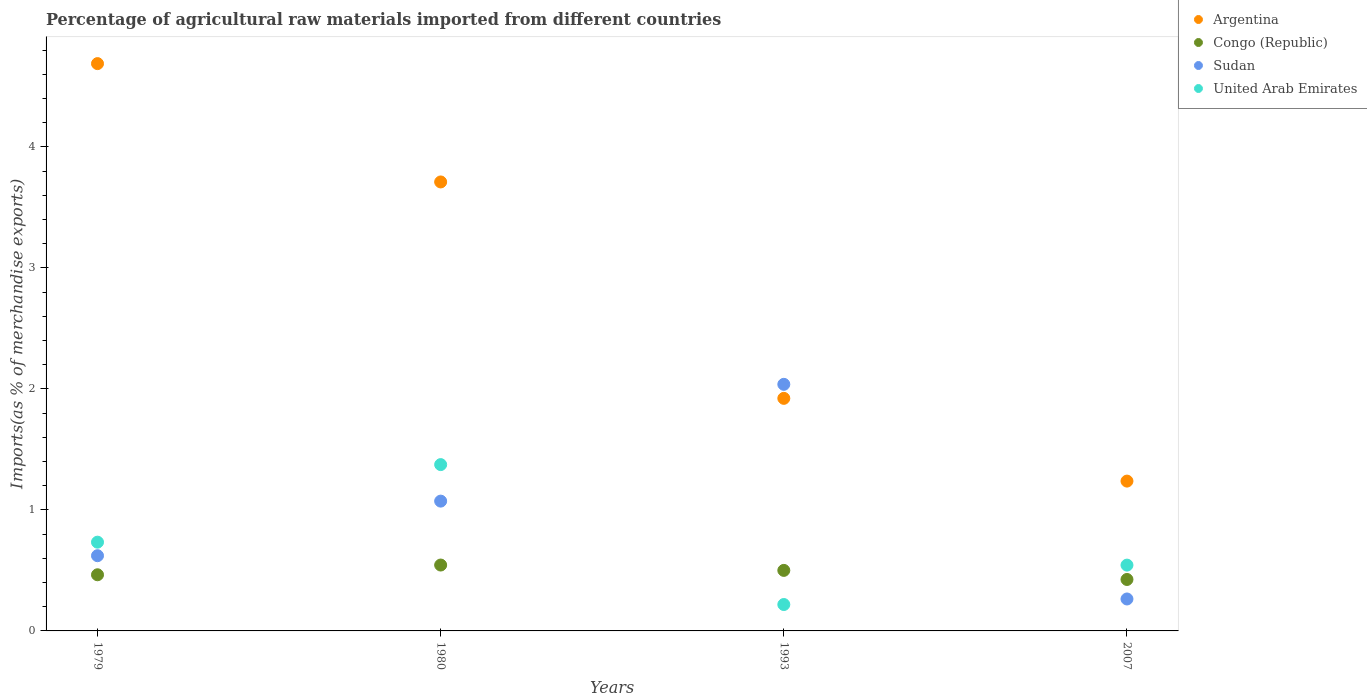How many different coloured dotlines are there?
Your response must be concise. 4. What is the percentage of imports to different countries in Argentina in 1979?
Offer a terse response. 4.69. Across all years, what is the maximum percentage of imports to different countries in Congo (Republic)?
Offer a very short reply. 0.54. Across all years, what is the minimum percentage of imports to different countries in Congo (Republic)?
Give a very brief answer. 0.43. What is the total percentage of imports to different countries in Sudan in the graph?
Provide a short and direct response. 4. What is the difference between the percentage of imports to different countries in United Arab Emirates in 1979 and that in 1993?
Make the answer very short. 0.52. What is the difference between the percentage of imports to different countries in Congo (Republic) in 1979 and the percentage of imports to different countries in United Arab Emirates in 2007?
Your response must be concise. -0.08. What is the average percentage of imports to different countries in Sudan per year?
Provide a succinct answer. 1. In the year 1980, what is the difference between the percentage of imports to different countries in Argentina and percentage of imports to different countries in Congo (Republic)?
Your answer should be very brief. 3.17. In how many years, is the percentage of imports to different countries in Argentina greater than 4.4 %?
Your answer should be very brief. 1. What is the ratio of the percentage of imports to different countries in Congo (Republic) in 1980 to that in 2007?
Provide a succinct answer. 1.28. What is the difference between the highest and the second highest percentage of imports to different countries in Congo (Republic)?
Your response must be concise. 0.04. What is the difference between the highest and the lowest percentage of imports to different countries in Congo (Republic)?
Offer a very short reply. 0.12. In how many years, is the percentage of imports to different countries in Sudan greater than the average percentage of imports to different countries in Sudan taken over all years?
Provide a short and direct response. 2. Is the sum of the percentage of imports to different countries in Argentina in 1979 and 1980 greater than the maximum percentage of imports to different countries in Congo (Republic) across all years?
Your answer should be very brief. Yes. Is it the case that in every year, the sum of the percentage of imports to different countries in United Arab Emirates and percentage of imports to different countries in Congo (Republic)  is greater than the percentage of imports to different countries in Sudan?
Offer a very short reply. No. Is the percentage of imports to different countries in Argentina strictly greater than the percentage of imports to different countries in Congo (Republic) over the years?
Your answer should be very brief. Yes. How many dotlines are there?
Offer a terse response. 4. What is the difference between two consecutive major ticks on the Y-axis?
Make the answer very short. 1. Does the graph contain any zero values?
Your answer should be very brief. No. Does the graph contain grids?
Give a very brief answer. No. How many legend labels are there?
Give a very brief answer. 4. How are the legend labels stacked?
Make the answer very short. Vertical. What is the title of the graph?
Make the answer very short. Percentage of agricultural raw materials imported from different countries. Does "Guam" appear as one of the legend labels in the graph?
Your response must be concise. No. What is the label or title of the Y-axis?
Offer a terse response. Imports(as % of merchandise exports). What is the Imports(as % of merchandise exports) in Argentina in 1979?
Your answer should be compact. 4.69. What is the Imports(as % of merchandise exports) in Congo (Republic) in 1979?
Your answer should be compact. 0.46. What is the Imports(as % of merchandise exports) in Sudan in 1979?
Your response must be concise. 0.62. What is the Imports(as % of merchandise exports) of United Arab Emirates in 1979?
Your answer should be compact. 0.73. What is the Imports(as % of merchandise exports) of Argentina in 1980?
Offer a terse response. 3.71. What is the Imports(as % of merchandise exports) of Congo (Republic) in 1980?
Ensure brevity in your answer.  0.54. What is the Imports(as % of merchandise exports) in Sudan in 1980?
Offer a very short reply. 1.07. What is the Imports(as % of merchandise exports) in United Arab Emirates in 1980?
Your answer should be compact. 1.37. What is the Imports(as % of merchandise exports) of Argentina in 1993?
Your response must be concise. 1.92. What is the Imports(as % of merchandise exports) of Congo (Republic) in 1993?
Ensure brevity in your answer.  0.5. What is the Imports(as % of merchandise exports) in Sudan in 1993?
Make the answer very short. 2.04. What is the Imports(as % of merchandise exports) of United Arab Emirates in 1993?
Your answer should be compact. 0.22. What is the Imports(as % of merchandise exports) in Argentina in 2007?
Keep it short and to the point. 1.24. What is the Imports(as % of merchandise exports) in Congo (Republic) in 2007?
Provide a short and direct response. 0.43. What is the Imports(as % of merchandise exports) in Sudan in 2007?
Your answer should be very brief. 0.26. What is the Imports(as % of merchandise exports) in United Arab Emirates in 2007?
Ensure brevity in your answer.  0.54. Across all years, what is the maximum Imports(as % of merchandise exports) of Argentina?
Provide a succinct answer. 4.69. Across all years, what is the maximum Imports(as % of merchandise exports) in Congo (Republic)?
Your answer should be very brief. 0.54. Across all years, what is the maximum Imports(as % of merchandise exports) in Sudan?
Ensure brevity in your answer.  2.04. Across all years, what is the maximum Imports(as % of merchandise exports) of United Arab Emirates?
Ensure brevity in your answer.  1.37. Across all years, what is the minimum Imports(as % of merchandise exports) in Argentina?
Keep it short and to the point. 1.24. Across all years, what is the minimum Imports(as % of merchandise exports) of Congo (Republic)?
Offer a terse response. 0.43. Across all years, what is the minimum Imports(as % of merchandise exports) of Sudan?
Offer a very short reply. 0.26. Across all years, what is the minimum Imports(as % of merchandise exports) of United Arab Emirates?
Your response must be concise. 0.22. What is the total Imports(as % of merchandise exports) of Argentina in the graph?
Your answer should be compact. 11.56. What is the total Imports(as % of merchandise exports) of Congo (Republic) in the graph?
Make the answer very short. 1.93. What is the total Imports(as % of merchandise exports) in Sudan in the graph?
Keep it short and to the point. 4. What is the total Imports(as % of merchandise exports) in United Arab Emirates in the graph?
Your response must be concise. 2.87. What is the difference between the Imports(as % of merchandise exports) of Argentina in 1979 and that in 1980?
Make the answer very short. 0.98. What is the difference between the Imports(as % of merchandise exports) in Congo (Republic) in 1979 and that in 1980?
Your response must be concise. -0.08. What is the difference between the Imports(as % of merchandise exports) of Sudan in 1979 and that in 1980?
Offer a terse response. -0.45. What is the difference between the Imports(as % of merchandise exports) in United Arab Emirates in 1979 and that in 1980?
Provide a short and direct response. -0.64. What is the difference between the Imports(as % of merchandise exports) of Argentina in 1979 and that in 1993?
Offer a very short reply. 2.77. What is the difference between the Imports(as % of merchandise exports) in Congo (Republic) in 1979 and that in 1993?
Your answer should be very brief. -0.04. What is the difference between the Imports(as % of merchandise exports) in Sudan in 1979 and that in 1993?
Offer a terse response. -1.42. What is the difference between the Imports(as % of merchandise exports) of United Arab Emirates in 1979 and that in 1993?
Your answer should be compact. 0.52. What is the difference between the Imports(as % of merchandise exports) in Argentina in 1979 and that in 2007?
Ensure brevity in your answer.  3.45. What is the difference between the Imports(as % of merchandise exports) of Congo (Republic) in 1979 and that in 2007?
Give a very brief answer. 0.04. What is the difference between the Imports(as % of merchandise exports) of Sudan in 1979 and that in 2007?
Ensure brevity in your answer.  0.36. What is the difference between the Imports(as % of merchandise exports) of United Arab Emirates in 1979 and that in 2007?
Your answer should be compact. 0.19. What is the difference between the Imports(as % of merchandise exports) of Argentina in 1980 and that in 1993?
Your answer should be very brief. 1.79. What is the difference between the Imports(as % of merchandise exports) in Congo (Republic) in 1980 and that in 1993?
Your answer should be very brief. 0.04. What is the difference between the Imports(as % of merchandise exports) of Sudan in 1980 and that in 1993?
Keep it short and to the point. -0.97. What is the difference between the Imports(as % of merchandise exports) in United Arab Emirates in 1980 and that in 1993?
Keep it short and to the point. 1.16. What is the difference between the Imports(as % of merchandise exports) of Argentina in 1980 and that in 2007?
Your response must be concise. 2.47. What is the difference between the Imports(as % of merchandise exports) of Congo (Republic) in 1980 and that in 2007?
Provide a succinct answer. 0.12. What is the difference between the Imports(as % of merchandise exports) in Sudan in 1980 and that in 2007?
Provide a short and direct response. 0.81. What is the difference between the Imports(as % of merchandise exports) of United Arab Emirates in 1980 and that in 2007?
Provide a succinct answer. 0.83. What is the difference between the Imports(as % of merchandise exports) of Argentina in 1993 and that in 2007?
Keep it short and to the point. 0.68. What is the difference between the Imports(as % of merchandise exports) of Congo (Republic) in 1993 and that in 2007?
Give a very brief answer. 0.08. What is the difference between the Imports(as % of merchandise exports) in Sudan in 1993 and that in 2007?
Offer a very short reply. 1.77. What is the difference between the Imports(as % of merchandise exports) in United Arab Emirates in 1993 and that in 2007?
Ensure brevity in your answer.  -0.33. What is the difference between the Imports(as % of merchandise exports) in Argentina in 1979 and the Imports(as % of merchandise exports) in Congo (Republic) in 1980?
Ensure brevity in your answer.  4.14. What is the difference between the Imports(as % of merchandise exports) of Argentina in 1979 and the Imports(as % of merchandise exports) of Sudan in 1980?
Your response must be concise. 3.62. What is the difference between the Imports(as % of merchandise exports) of Argentina in 1979 and the Imports(as % of merchandise exports) of United Arab Emirates in 1980?
Keep it short and to the point. 3.31. What is the difference between the Imports(as % of merchandise exports) of Congo (Republic) in 1979 and the Imports(as % of merchandise exports) of Sudan in 1980?
Offer a very short reply. -0.61. What is the difference between the Imports(as % of merchandise exports) of Congo (Republic) in 1979 and the Imports(as % of merchandise exports) of United Arab Emirates in 1980?
Provide a succinct answer. -0.91. What is the difference between the Imports(as % of merchandise exports) of Sudan in 1979 and the Imports(as % of merchandise exports) of United Arab Emirates in 1980?
Offer a terse response. -0.75. What is the difference between the Imports(as % of merchandise exports) of Argentina in 1979 and the Imports(as % of merchandise exports) of Congo (Republic) in 1993?
Make the answer very short. 4.19. What is the difference between the Imports(as % of merchandise exports) in Argentina in 1979 and the Imports(as % of merchandise exports) in Sudan in 1993?
Ensure brevity in your answer.  2.65. What is the difference between the Imports(as % of merchandise exports) of Argentina in 1979 and the Imports(as % of merchandise exports) of United Arab Emirates in 1993?
Offer a very short reply. 4.47. What is the difference between the Imports(as % of merchandise exports) of Congo (Republic) in 1979 and the Imports(as % of merchandise exports) of Sudan in 1993?
Give a very brief answer. -1.57. What is the difference between the Imports(as % of merchandise exports) of Congo (Republic) in 1979 and the Imports(as % of merchandise exports) of United Arab Emirates in 1993?
Ensure brevity in your answer.  0.25. What is the difference between the Imports(as % of merchandise exports) in Sudan in 1979 and the Imports(as % of merchandise exports) in United Arab Emirates in 1993?
Provide a short and direct response. 0.4. What is the difference between the Imports(as % of merchandise exports) in Argentina in 1979 and the Imports(as % of merchandise exports) in Congo (Republic) in 2007?
Provide a succinct answer. 4.26. What is the difference between the Imports(as % of merchandise exports) of Argentina in 1979 and the Imports(as % of merchandise exports) of Sudan in 2007?
Provide a short and direct response. 4.42. What is the difference between the Imports(as % of merchandise exports) of Argentina in 1979 and the Imports(as % of merchandise exports) of United Arab Emirates in 2007?
Keep it short and to the point. 4.14. What is the difference between the Imports(as % of merchandise exports) of Congo (Republic) in 1979 and the Imports(as % of merchandise exports) of United Arab Emirates in 2007?
Offer a very short reply. -0.08. What is the difference between the Imports(as % of merchandise exports) in Sudan in 1979 and the Imports(as % of merchandise exports) in United Arab Emirates in 2007?
Offer a terse response. 0.08. What is the difference between the Imports(as % of merchandise exports) of Argentina in 1980 and the Imports(as % of merchandise exports) of Congo (Republic) in 1993?
Provide a short and direct response. 3.21. What is the difference between the Imports(as % of merchandise exports) of Argentina in 1980 and the Imports(as % of merchandise exports) of Sudan in 1993?
Provide a short and direct response. 1.67. What is the difference between the Imports(as % of merchandise exports) in Argentina in 1980 and the Imports(as % of merchandise exports) in United Arab Emirates in 1993?
Offer a very short reply. 3.49. What is the difference between the Imports(as % of merchandise exports) in Congo (Republic) in 1980 and the Imports(as % of merchandise exports) in Sudan in 1993?
Give a very brief answer. -1.49. What is the difference between the Imports(as % of merchandise exports) in Congo (Republic) in 1980 and the Imports(as % of merchandise exports) in United Arab Emirates in 1993?
Your answer should be compact. 0.33. What is the difference between the Imports(as % of merchandise exports) of Sudan in 1980 and the Imports(as % of merchandise exports) of United Arab Emirates in 1993?
Ensure brevity in your answer.  0.85. What is the difference between the Imports(as % of merchandise exports) of Argentina in 1980 and the Imports(as % of merchandise exports) of Congo (Republic) in 2007?
Offer a terse response. 3.29. What is the difference between the Imports(as % of merchandise exports) of Argentina in 1980 and the Imports(as % of merchandise exports) of Sudan in 2007?
Your answer should be compact. 3.45. What is the difference between the Imports(as % of merchandise exports) of Argentina in 1980 and the Imports(as % of merchandise exports) of United Arab Emirates in 2007?
Offer a terse response. 3.17. What is the difference between the Imports(as % of merchandise exports) of Congo (Republic) in 1980 and the Imports(as % of merchandise exports) of Sudan in 2007?
Provide a succinct answer. 0.28. What is the difference between the Imports(as % of merchandise exports) in Congo (Republic) in 1980 and the Imports(as % of merchandise exports) in United Arab Emirates in 2007?
Keep it short and to the point. 0. What is the difference between the Imports(as % of merchandise exports) of Sudan in 1980 and the Imports(as % of merchandise exports) of United Arab Emirates in 2007?
Offer a terse response. 0.53. What is the difference between the Imports(as % of merchandise exports) of Argentina in 1993 and the Imports(as % of merchandise exports) of Congo (Republic) in 2007?
Offer a terse response. 1.5. What is the difference between the Imports(as % of merchandise exports) in Argentina in 1993 and the Imports(as % of merchandise exports) in Sudan in 2007?
Your answer should be very brief. 1.66. What is the difference between the Imports(as % of merchandise exports) in Argentina in 1993 and the Imports(as % of merchandise exports) in United Arab Emirates in 2007?
Offer a terse response. 1.38. What is the difference between the Imports(as % of merchandise exports) of Congo (Republic) in 1993 and the Imports(as % of merchandise exports) of Sudan in 2007?
Keep it short and to the point. 0.24. What is the difference between the Imports(as % of merchandise exports) of Congo (Republic) in 1993 and the Imports(as % of merchandise exports) of United Arab Emirates in 2007?
Provide a succinct answer. -0.04. What is the difference between the Imports(as % of merchandise exports) of Sudan in 1993 and the Imports(as % of merchandise exports) of United Arab Emirates in 2007?
Make the answer very short. 1.49. What is the average Imports(as % of merchandise exports) of Argentina per year?
Offer a terse response. 2.89. What is the average Imports(as % of merchandise exports) in Congo (Republic) per year?
Make the answer very short. 0.48. What is the average Imports(as % of merchandise exports) of United Arab Emirates per year?
Offer a terse response. 0.72. In the year 1979, what is the difference between the Imports(as % of merchandise exports) of Argentina and Imports(as % of merchandise exports) of Congo (Republic)?
Offer a terse response. 4.22. In the year 1979, what is the difference between the Imports(as % of merchandise exports) of Argentina and Imports(as % of merchandise exports) of Sudan?
Provide a succinct answer. 4.07. In the year 1979, what is the difference between the Imports(as % of merchandise exports) in Argentina and Imports(as % of merchandise exports) in United Arab Emirates?
Offer a very short reply. 3.96. In the year 1979, what is the difference between the Imports(as % of merchandise exports) in Congo (Republic) and Imports(as % of merchandise exports) in Sudan?
Ensure brevity in your answer.  -0.16. In the year 1979, what is the difference between the Imports(as % of merchandise exports) in Congo (Republic) and Imports(as % of merchandise exports) in United Arab Emirates?
Your answer should be very brief. -0.27. In the year 1979, what is the difference between the Imports(as % of merchandise exports) in Sudan and Imports(as % of merchandise exports) in United Arab Emirates?
Give a very brief answer. -0.11. In the year 1980, what is the difference between the Imports(as % of merchandise exports) in Argentina and Imports(as % of merchandise exports) in Congo (Republic)?
Give a very brief answer. 3.17. In the year 1980, what is the difference between the Imports(as % of merchandise exports) in Argentina and Imports(as % of merchandise exports) in Sudan?
Your answer should be compact. 2.64. In the year 1980, what is the difference between the Imports(as % of merchandise exports) of Argentina and Imports(as % of merchandise exports) of United Arab Emirates?
Your answer should be very brief. 2.34. In the year 1980, what is the difference between the Imports(as % of merchandise exports) in Congo (Republic) and Imports(as % of merchandise exports) in Sudan?
Provide a succinct answer. -0.53. In the year 1980, what is the difference between the Imports(as % of merchandise exports) in Congo (Republic) and Imports(as % of merchandise exports) in United Arab Emirates?
Provide a short and direct response. -0.83. In the year 1980, what is the difference between the Imports(as % of merchandise exports) in Sudan and Imports(as % of merchandise exports) in United Arab Emirates?
Provide a succinct answer. -0.3. In the year 1993, what is the difference between the Imports(as % of merchandise exports) of Argentina and Imports(as % of merchandise exports) of Congo (Republic)?
Offer a terse response. 1.42. In the year 1993, what is the difference between the Imports(as % of merchandise exports) of Argentina and Imports(as % of merchandise exports) of Sudan?
Offer a terse response. -0.12. In the year 1993, what is the difference between the Imports(as % of merchandise exports) in Argentina and Imports(as % of merchandise exports) in United Arab Emirates?
Provide a succinct answer. 1.7. In the year 1993, what is the difference between the Imports(as % of merchandise exports) in Congo (Republic) and Imports(as % of merchandise exports) in Sudan?
Your answer should be compact. -1.54. In the year 1993, what is the difference between the Imports(as % of merchandise exports) of Congo (Republic) and Imports(as % of merchandise exports) of United Arab Emirates?
Keep it short and to the point. 0.28. In the year 1993, what is the difference between the Imports(as % of merchandise exports) of Sudan and Imports(as % of merchandise exports) of United Arab Emirates?
Provide a succinct answer. 1.82. In the year 2007, what is the difference between the Imports(as % of merchandise exports) in Argentina and Imports(as % of merchandise exports) in Congo (Republic)?
Provide a short and direct response. 0.81. In the year 2007, what is the difference between the Imports(as % of merchandise exports) of Argentina and Imports(as % of merchandise exports) of Sudan?
Offer a very short reply. 0.97. In the year 2007, what is the difference between the Imports(as % of merchandise exports) of Argentina and Imports(as % of merchandise exports) of United Arab Emirates?
Offer a very short reply. 0.69. In the year 2007, what is the difference between the Imports(as % of merchandise exports) of Congo (Republic) and Imports(as % of merchandise exports) of Sudan?
Offer a terse response. 0.16. In the year 2007, what is the difference between the Imports(as % of merchandise exports) of Congo (Republic) and Imports(as % of merchandise exports) of United Arab Emirates?
Ensure brevity in your answer.  -0.12. In the year 2007, what is the difference between the Imports(as % of merchandise exports) in Sudan and Imports(as % of merchandise exports) in United Arab Emirates?
Your response must be concise. -0.28. What is the ratio of the Imports(as % of merchandise exports) in Argentina in 1979 to that in 1980?
Make the answer very short. 1.26. What is the ratio of the Imports(as % of merchandise exports) in Congo (Republic) in 1979 to that in 1980?
Your response must be concise. 0.85. What is the ratio of the Imports(as % of merchandise exports) of Sudan in 1979 to that in 1980?
Provide a succinct answer. 0.58. What is the ratio of the Imports(as % of merchandise exports) in United Arab Emirates in 1979 to that in 1980?
Make the answer very short. 0.53. What is the ratio of the Imports(as % of merchandise exports) in Argentina in 1979 to that in 1993?
Your answer should be very brief. 2.44. What is the ratio of the Imports(as % of merchandise exports) in Congo (Republic) in 1979 to that in 1993?
Ensure brevity in your answer.  0.93. What is the ratio of the Imports(as % of merchandise exports) of Sudan in 1979 to that in 1993?
Provide a succinct answer. 0.3. What is the ratio of the Imports(as % of merchandise exports) of United Arab Emirates in 1979 to that in 1993?
Provide a short and direct response. 3.36. What is the ratio of the Imports(as % of merchandise exports) in Argentina in 1979 to that in 2007?
Your response must be concise. 3.79. What is the ratio of the Imports(as % of merchandise exports) of Congo (Republic) in 1979 to that in 2007?
Offer a very short reply. 1.09. What is the ratio of the Imports(as % of merchandise exports) of Sudan in 1979 to that in 2007?
Offer a terse response. 2.35. What is the ratio of the Imports(as % of merchandise exports) of United Arab Emirates in 1979 to that in 2007?
Offer a very short reply. 1.35. What is the ratio of the Imports(as % of merchandise exports) in Argentina in 1980 to that in 1993?
Your answer should be compact. 1.93. What is the ratio of the Imports(as % of merchandise exports) in Congo (Republic) in 1980 to that in 1993?
Your answer should be compact. 1.09. What is the ratio of the Imports(as % of merchandise exports) in Sudan in 1980 to that in 1993?
Make the answer very short. 0.53. What is the ratio of the Imports(as % of merchandise exports) in United Arab Emirates in 1980 to that in 1993?
Offer a very short reply. 6.3. What is the ratio of the Imports(as % of merchandise exports) in Argentina in 1980 to that in 2007?
Your answer should be very brief. 3. What is the ratio of the Imports(as % of merchandise exports) in Congo (Republic) in 1980 to that in 2007?
Provide a succinct answer. 1.28. What is the ratio of the Imports(as % of merchandise exports) of Sudan in 1980 to that in 2007?
Make the answer very short. 4.06. What is the ratio of the Imports(as % of merchandise exports) of United Arab Emirates in 1980 to that in 2007?
Provide a succinct answer. 2.53. What is the ratio of the Imports(as % of merchandise exports) in Argentina in 1993 to that in 2007?
Offer a terse response. 1.55. What is the ratio of the Imports(as % of merchandise exports) of Congo (Republic) in 1993 to that in 2007?
Offer a terse response. 1.18. What is the ratio of the Imports(as % of merchandise exports) in Sudan in 1993 to that in 2007?
Make the answer very short. 7.72. What is the ratio of the Imports(as % of merchandise exports) in United Arab Emirates in 1993 to that in 2007?
Offer a very short reply. 0.4. What is the difference between the highest and the second highest Imports(as % of merchandise exports) in Argentina?
Provide a succinct answer. 0.98. What is the difference between the highest and the second highest Imports(as % of merchandise exports) in Congo (Republic)?
Provide a succinct answer. 0.04. What is the difference between the highest and the second highest Imports(as % of merchandise exports) in Sudan?
Offer a terse response. 0.97. What is the difference between the highest and the second highest Imports(as % of merchandise exports) of United Arab Emirates?
Provide a short and direct response. 0.64. What is the difference between the highest and the lowest Imports(as % of merchandise exports) in Argentina?
Provide a short and direct response. 3.45. What is the difference between the highest and the lowest Imports(as % of merchandise exports) in Congo (Republic)?
Your answer should be compact. 0.12. What is the difference between the highest and the lowest Imports(as % of merchandise exports) of Sudan?
Offer a terse response. 1.77. What is the difference between the highest and the lowest Imports(as % of merchandise exports) of United Arab Emirates?
Your response must be concise. 1.16. 